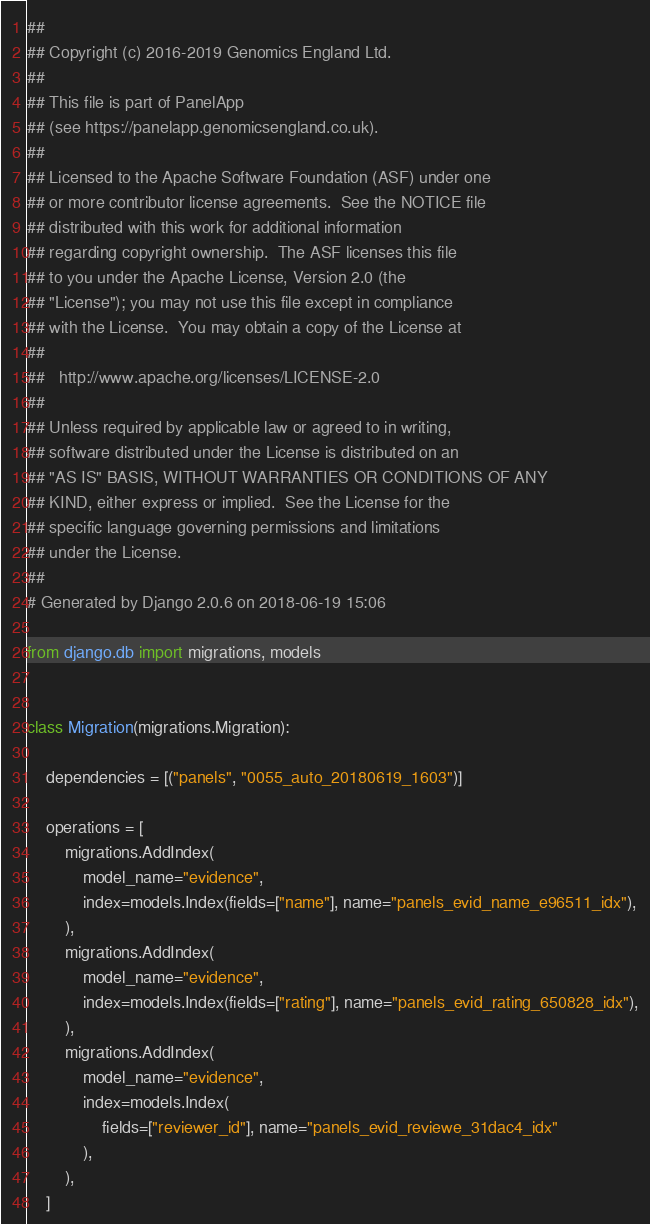<code> <loc_0><loc_0><loc_500><loc_500><_Python_>##
## Copyright (c) 2016-2019 Genomics England Ltd.
##
## This file is part of PanelApp
## (see https://panelapp.genomicsengland.co.uk).
##
## Licensed to the Apache Software Foundation (ASF) under one
## or more contributor license agreements.  See the NOTICE file
## distributed with this work for additional information
## regarding copyright ownership.  The ASF licenses this file
## to you under the Apache License, Version 2.0 (the
## "License"); you may not use this file except in compliance
## with the License.  You may obtain a copy of the License at
##
##   http://www.apache.org/licenses/LICENSE-2.0
##
## Unless required by applicable law or agreed to in writing,
## software distributed under the License is distributed on an
## "AS IS" BASIS, WITHOUT WARRANTIES OR CONDITIONS OF ANY
## KIND, either express or implied.  See the License for the
## specific language governing permissions and limitations
## under the License.
##
# Generated by Django 2.0.6 on 2018-06-19 15:06

from django.db import migrations, models


class Migration(migrations.Migration):

    dependencies = [("panels", "0055_auto_20180619_1603")]

    operations = [
        migrations.AddIndex(
            model_name="evidence",
            index=models.Index(fields=["name"], name="panels_evid_name_e96511_idx"),
        ),
        migrations.AddIndex(
            model_name="evidence",
            index=models.Index(fields=["rating"], name="panels_evid_rating_650828_idx"),
        ),
        migrations.AddIndex(
            model_name="evidence",
            index=models.Index(
                fields=["reviewer_id"], name="panels_evid_reviewe_31dac4_idx"
            ),
        ),
    ]
</code> 